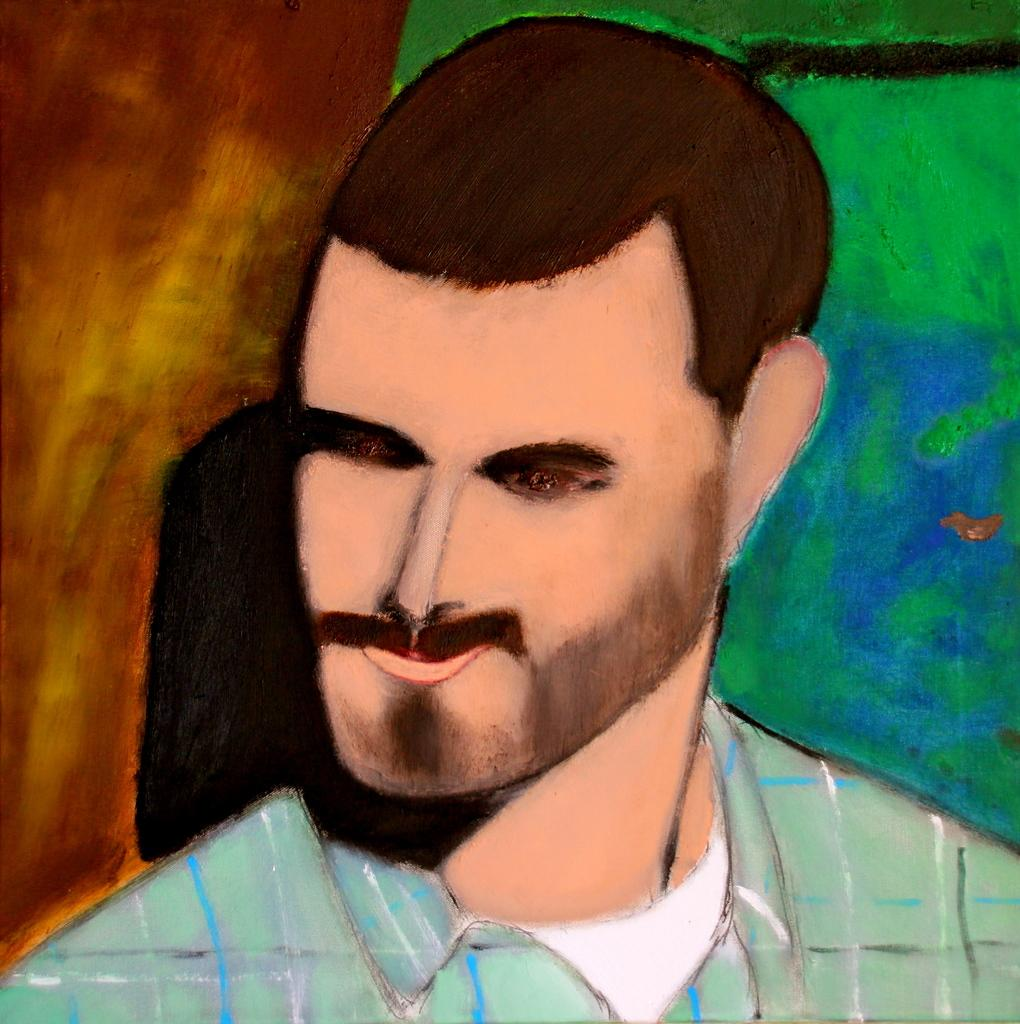What is depicted in the image? There is a painting of a man in the image. Can you describe the background of the painting? The background of the painting is colorful. What type of advertisement can be seen on the drawer in the image? There is no drawer or advertisement present in the image; it features a painting of a man with a colorful background. 